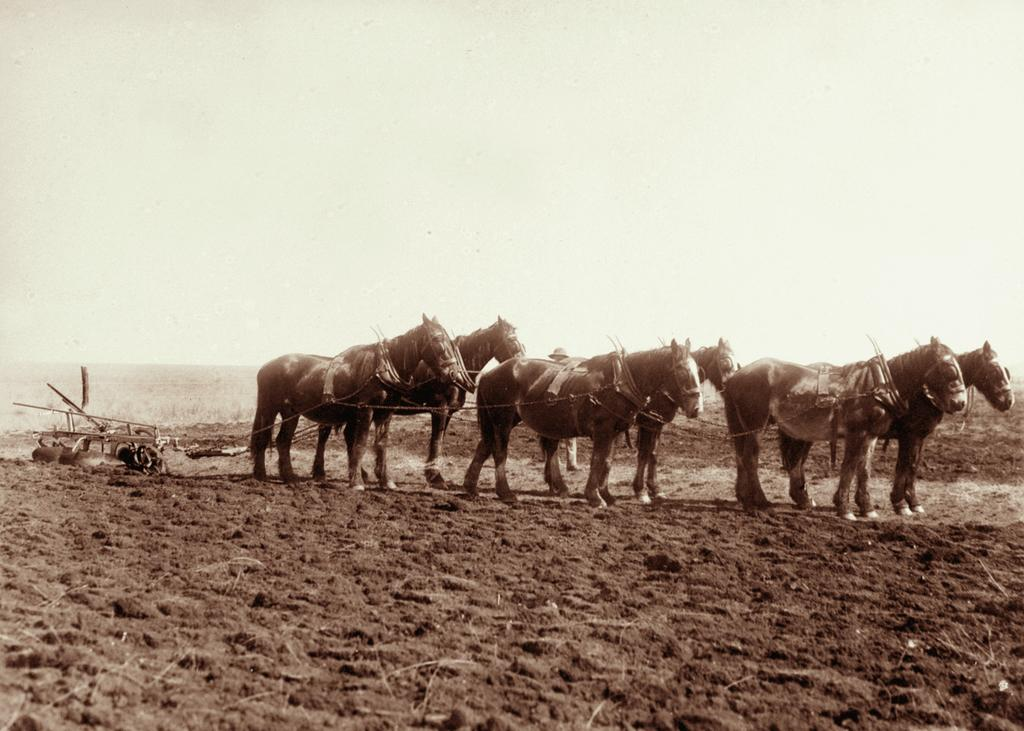What animals can be seen in the field in the image? There are horses in the field in the image. What is the main setting of the image? The field is visible in the image. What type of vegetation can be seen in the background of the image? There are plants in the background of the image. What type of car is parked near the horses in the image? There is no car present in the image; it features horses in a field with plants in the background. 